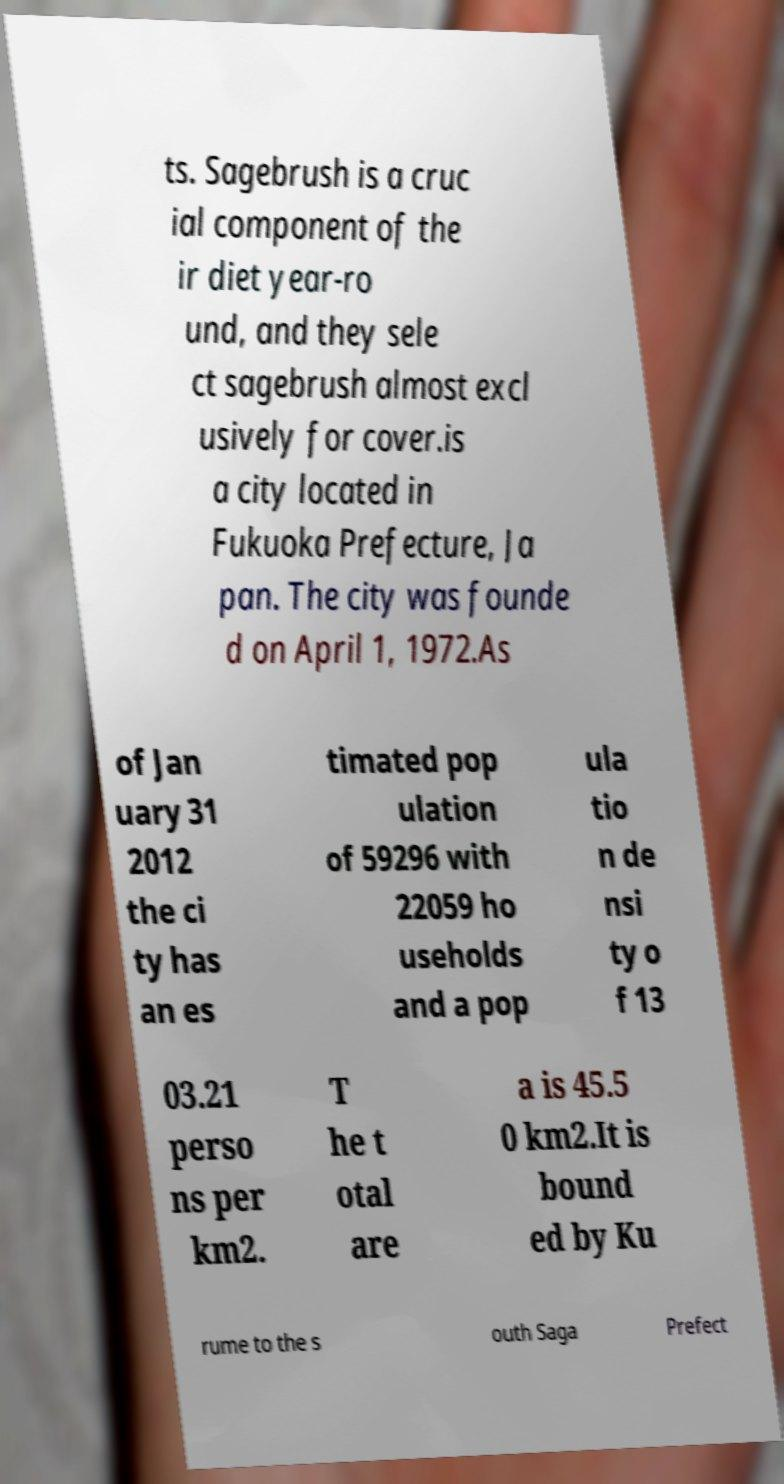Could you assist in decoding the text presented in this image and type it out clearly? ts. Sagebrush is a cruc ial component of the ir diet year-ro und, and they sele ct sagebrush almost excl usively for cover.is a city located in Fukuoka Prefecture, Ja pan. The city was founde d on April 1, 1972.As of Jan uary 31 2012 the ci ty has an es timated pop ulation of 59296 with 22059 ho useholds and a pop ula tio n de nsi ty o f 13 03.21 perso ns per km2. T he t otal are a is 45.5 0 km2.It is bound ed by Ku rume to the s outh Saga Prefect 